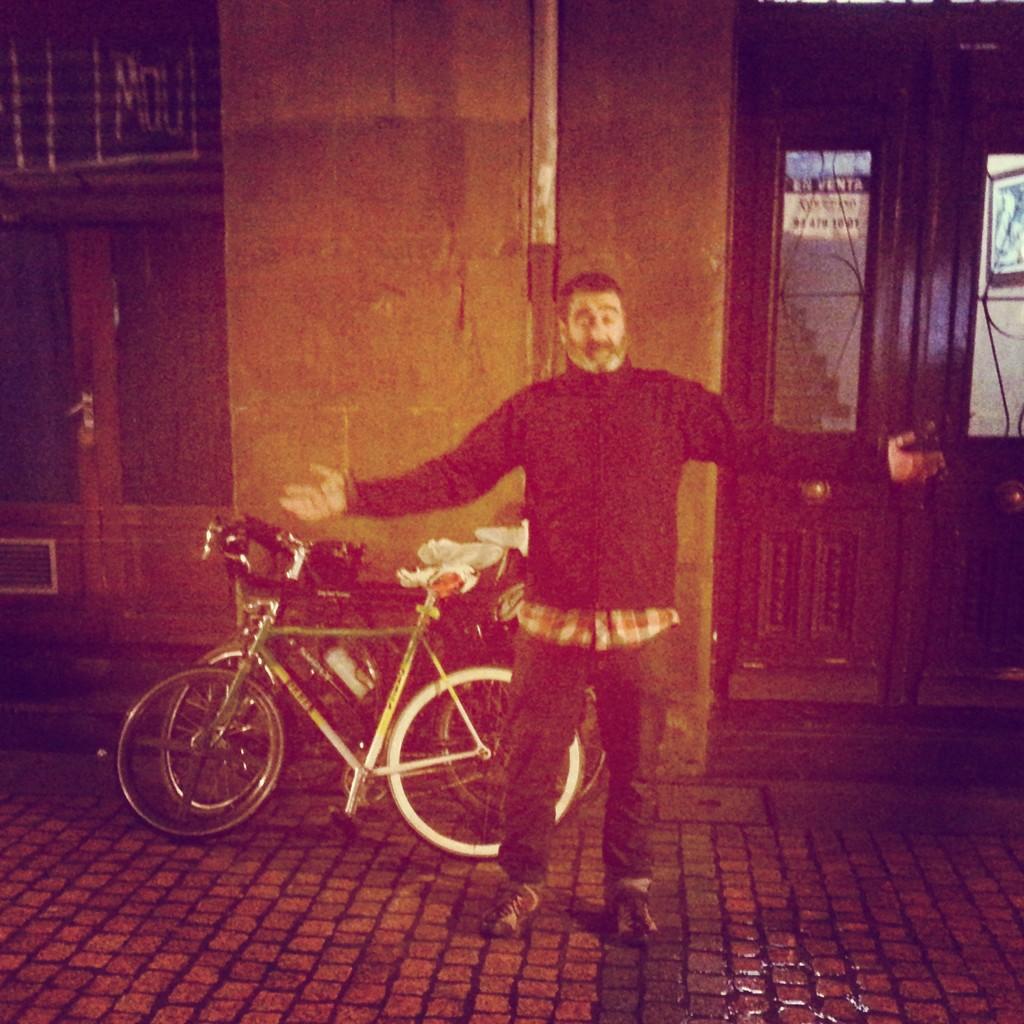In one or two sentences, can you explain what this image depicts? In this image there is a man standing on the ground, there are bicycles, there is a wall behind the man, there is a door towards the left of the image, there is a door towards the right of the image, there is staircase, there is a wall towards the right of the image, there is a photo frame on the wall. 